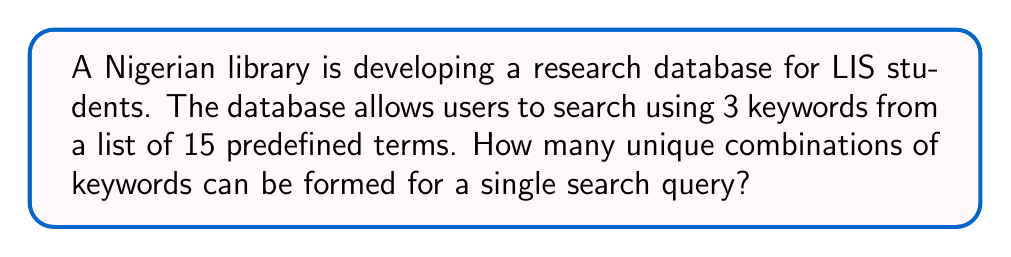Could you help me with this problem? Let's approach this step-by-step:

1) This is a combination problem because:
   - The order of selecting the keywords doesn't matter (e.g., "Library, Science, Research" is the same as "Research, Library, Science").
   - We are selecting 3 keywords out of 15, without replacement (a keyword can't be used twice in the same query).

2) The formula for combinations is:

   $$C(n,r) = \frac{n!}{r!(n-r)!}$$

   Where $n$ is the total number of items to choose from, and $r$ is the number of items being chosen.

3) In this case:
   $n = 15$ (total number of predefined terms)
   $r = 3$ (number of keywords in each query)

4) Substituting these values into our formula:

   $$C(15,3) = \frac{15!}{3!(15-3)!} = \frac{15!}{3!12!}$$

5) Expanding this:
   
   $$\frac{15 \times 14 \times 13 \times 12!}{(3 \times 2 \times 1) \times 12!}$$

6) The $12!$ cancels out in the numerator and denominator:

   $$\frac{15 \times 14 \times 13}{3 \times 2 \times 1} = \frac{2730}{6} = 455$$

Therefore, there are 455 unique combinations of keywords possible for a single search query.
Answer: 455 